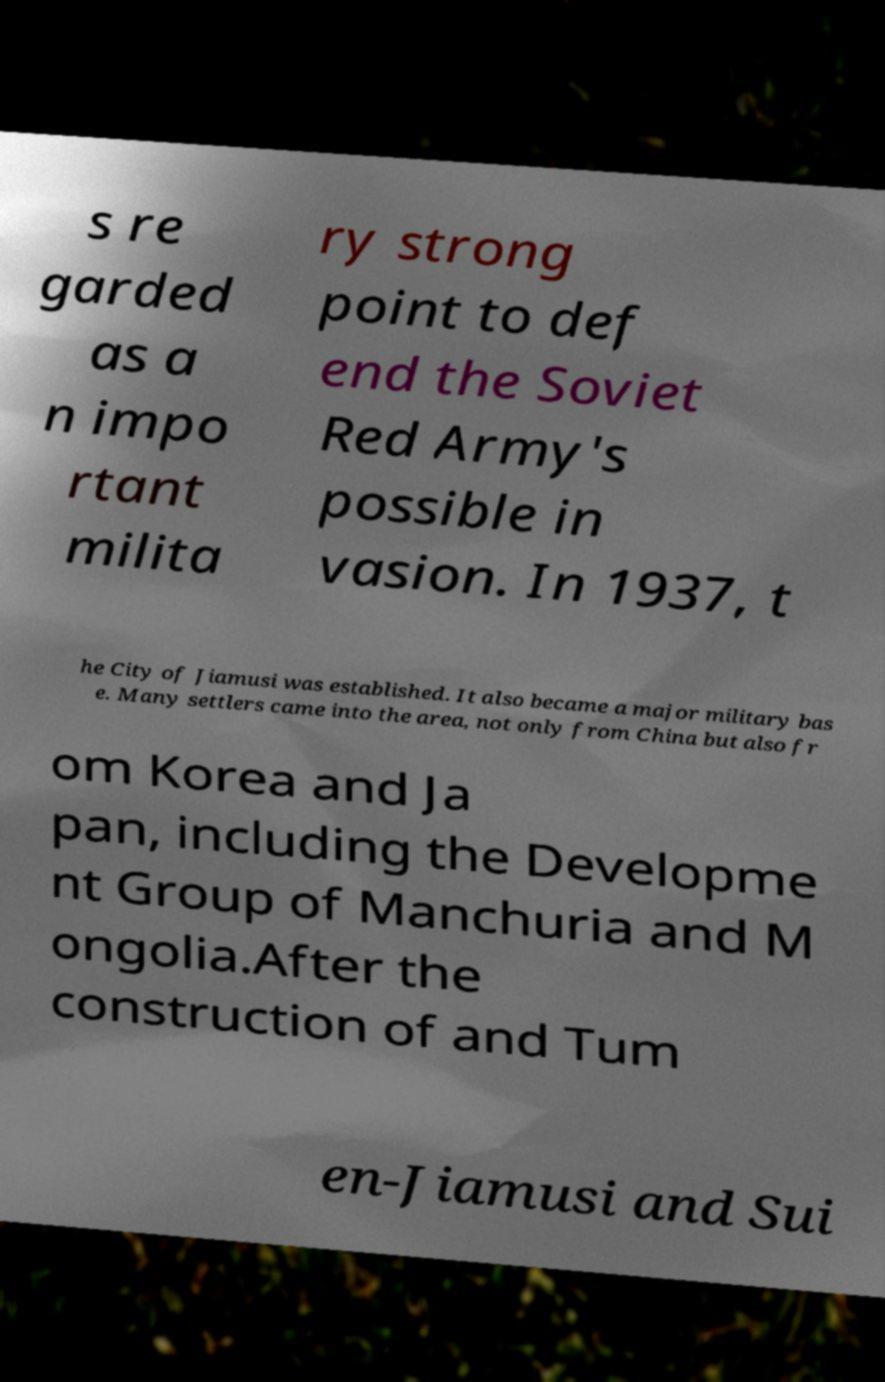I need the written content from this picture converted into text. Can you do that? s re garded as a n impo rtant milita ry strong point to def end the Soviet Red Army's possible in vasion. In 1937, t he City of Jiamusi was established. It also became a major military bas e. Many settlers came into the area, not only from China but also fr om Korea and Ja pan, including the Developme nt Group of Manchuria and M ongolia.After the construction of and Tum en-Jiamusi and Sui 